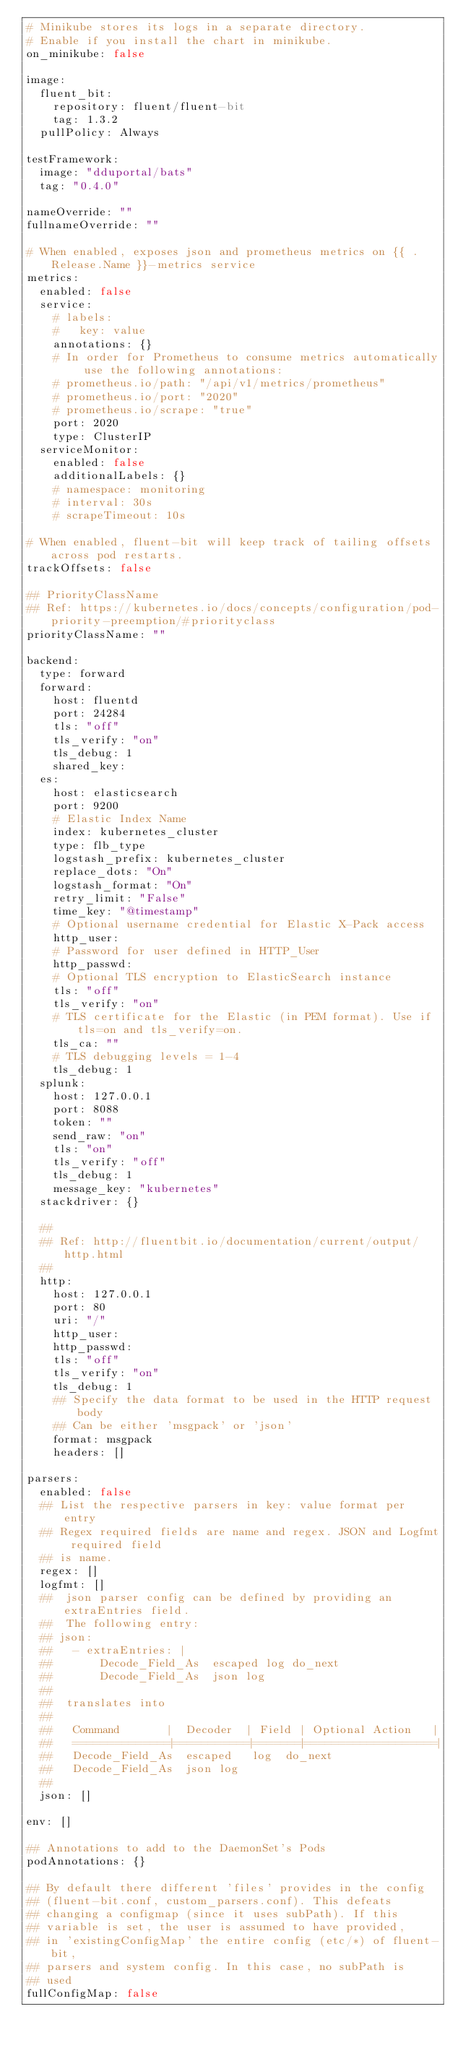<code> <loc_0><loc_0><loc_500><loc_500><_YAML_># Minikube stores its logs in a separate directory.
# Enable if you install the chart in minikube.
on_minikube: false

image:
  fluent_bit:
    repository: fluent/fluent-bit
    tag: 1.3.2
  pullPolicy: Always

testFramework:
  image: "dduportal/bats"
  tag: "0.4.0"

nameOverride: ""
fullnameOverride: ""

# When enabled, exposes json and prometheus metrics on {{ .Release.Name }}-metrics service
metrics:
  enabled: false
  service:
    # labels:
    #   key: value
    annotations: {}
    # In order for Prometheus to consume metrics automatically use the following annotations:
    # prometheus.io/path: "/api/v1/metrics/prometheus"
    # prometheus.io/port: "2020"
    # prometheus.io/scrape: "true"
    port: 2020
    type: ClusterIP
  serviceMonitor:
    enabled: false
    additionalLabels: {}
    # namespace: monitoring
    # interval: 30s
    # scrapeTimeout: 10s

# When enabled, fluent-bit will keep track of tailing offsets across pod restarts.
trackOffsets: false

## PriorityClassName
## Ref: https://kubernetes.io/docs/concepts/configuration/pod-priority-preemption/#priorityclass
priorityClassName: ""

backend:
  type: forward
  forward:
    host: fluentd
    port: 24284
    tls: "off"
    tls_verify: "on"
    tls_debug: 1
    shared_key:
  es:
    host: elasticsearch
    port: 9200
    # Elastic Index Name
    index: kubernetes_cluster
    type: flb_type
    logstash_prefix: kubernetes_cluster
    replace_dots: "On"
    logstash_format: "On"
    retry_limit: "False"
    time_key: "@timestamp"
    # Optional username credential for Elastic X-Pack access
    http_user:
    # Password for user defined in HTTP_User
    http_passwd:
    # Optional TLS encryption to ElasticSearch instance
    tls: "off"
    tls_verify: "on"
    # TLS certificate for the Elastic (in PEM format). Use if tls=on and tls_verify=on.
    tls_ca: ""
    # TLS debugging levels = 1-4
    tls_debug: 1
  splunk:
    host: 127.0.0.1
    port: 8088
    token: ""
    send_raw: "on"
    tls: "on"
    tls_verify: "off"
    tls_debug: 1
    message_key: "kubernetes"
  stackdriver: {}

  ##
  ## Ref: http://fluentbit.io/documentation/current/output/http.html
  ##
  http:
    host: 127.0.0.1
    port: 80
    uri: "/"
    http_user:
    http_passwd:
    tls: "off"
    tls_verify: "on"
    tls_debug: 1
    ## Specify the data format to be used in the HTTP request body
    ## Can be either 'msgpack' or 'json'
    format: msgpack
    headers: []

parsers:
  enabled: false
  ## List the respective parsers in key: value format per entry
  ## Regex required fields are name and regex. JSON and Logfmt required field
  ## is name.
  regex: []
  logfmt: []
  ##  json parser config can be defined by providing an extraEntries field.
  ##  The following entry:
  ## json:
  ##   - extraEntries: |
  ##       Decode_Field_As  escaped log do_next
  ##       Decode_Field_As  json log
  ##
  ##  translates into
  ##
  ##   Command       |  Decoder  | Field | Optional Action   |
  ##   ==============|===========|=======|===================|
  ##   Decode_Field_As  escaped   log  do_next
  ##   Decode_Field_As  json log
  ##
  json: []

env: []

## Annotations to add to the DaemonSet's Pods
podAnnotations: {}

## By default there different 'files' provides in the config
## (fluent-bit.conf, custom_parsers.conf). This defeats
## changing a configmap (since it uses subPath). If this
## variable is set, the user is assumed to have provided,
## in 'existingConfigMap' the entire config (etc/*) of fluent-bit,
## parsers and system config. In this case, no subPath is
## used
fullConfigMap: false
</code> 